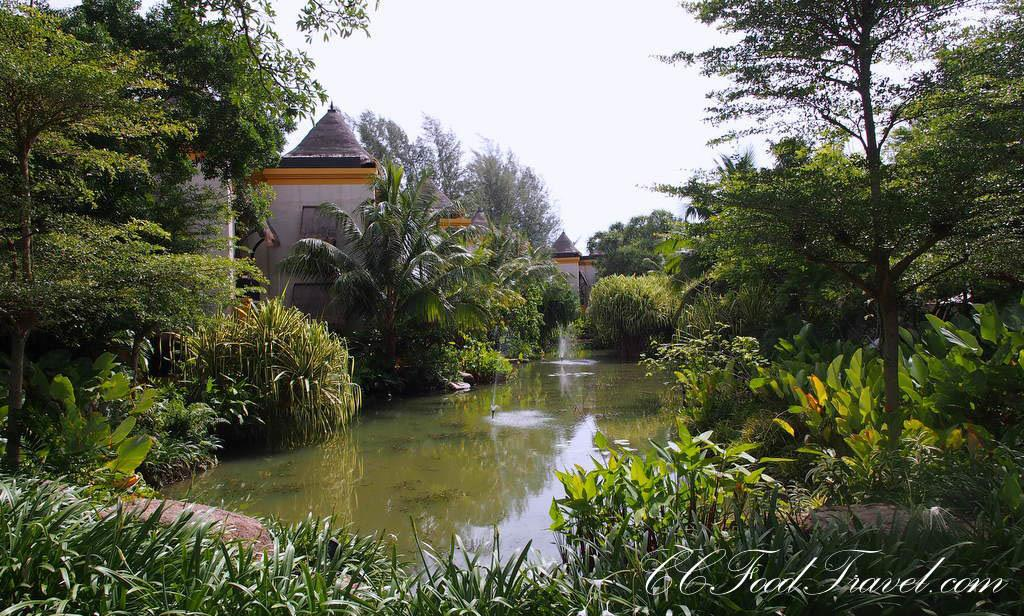What type of structure is present in the image? There is a house in the image. What natural elements can be seen in the image? Trees, plants, water, and sky are visible in the image. Where is the text located in the image? The text is at the bottom of the image. What word is being spoken by the family in the image? There is no family present in the image, and no words are being spoken. What type of teeth can be seen in the image? There are no teeth visible in the image. 